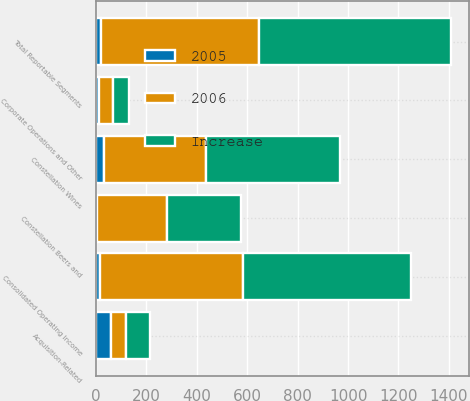Convert chart to OTSL. <chart><loc_0><loc_0><loc_500><loc_500><stacked_bar_chart><ecel><fcel>Constellation Wines<fcel>Constellation Beers and<fcel>Corporate Operations and Other<fcel>Total Reportable Segments<fcel>Acquisition-Related<fcel>Consolidated Operating Income<nl><fcel>Increase<fcel>530.4<fcel>292.6<fcel>63<fcel>760<fcel>93.9<fcel>666.1<nl><fcel>2006<fcel>406.6<fcel>276.1<fcel>56<fcel>626.7<fcel>58.8<fcel>567.9<nl><fcel>2005<fcel>30<fcel>6<fcel>13<fcel>21<fcel>60<fcel>17<nl></chart> 